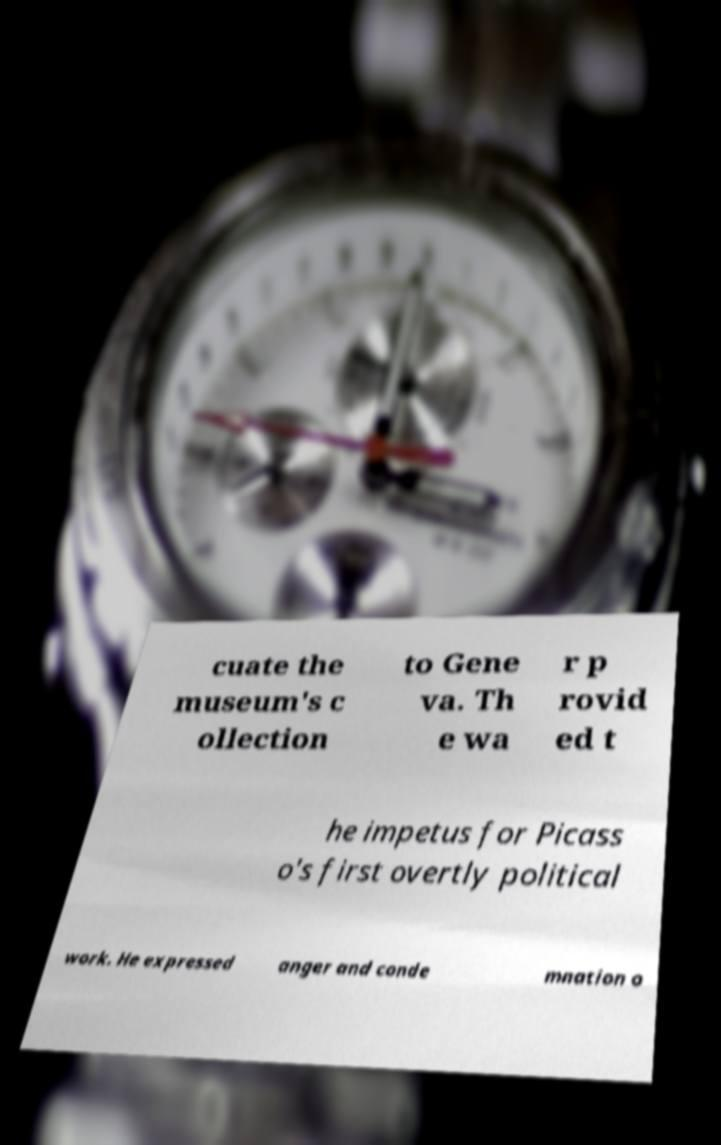For documentation purposes, I need the text within this image transcribed. Could you provide that? cuate the museum's c ollection to Gene va. Th e wa r p rovid ed t he impetus for Picass o's first overtly political work. He expressed anger and conde mnation o 